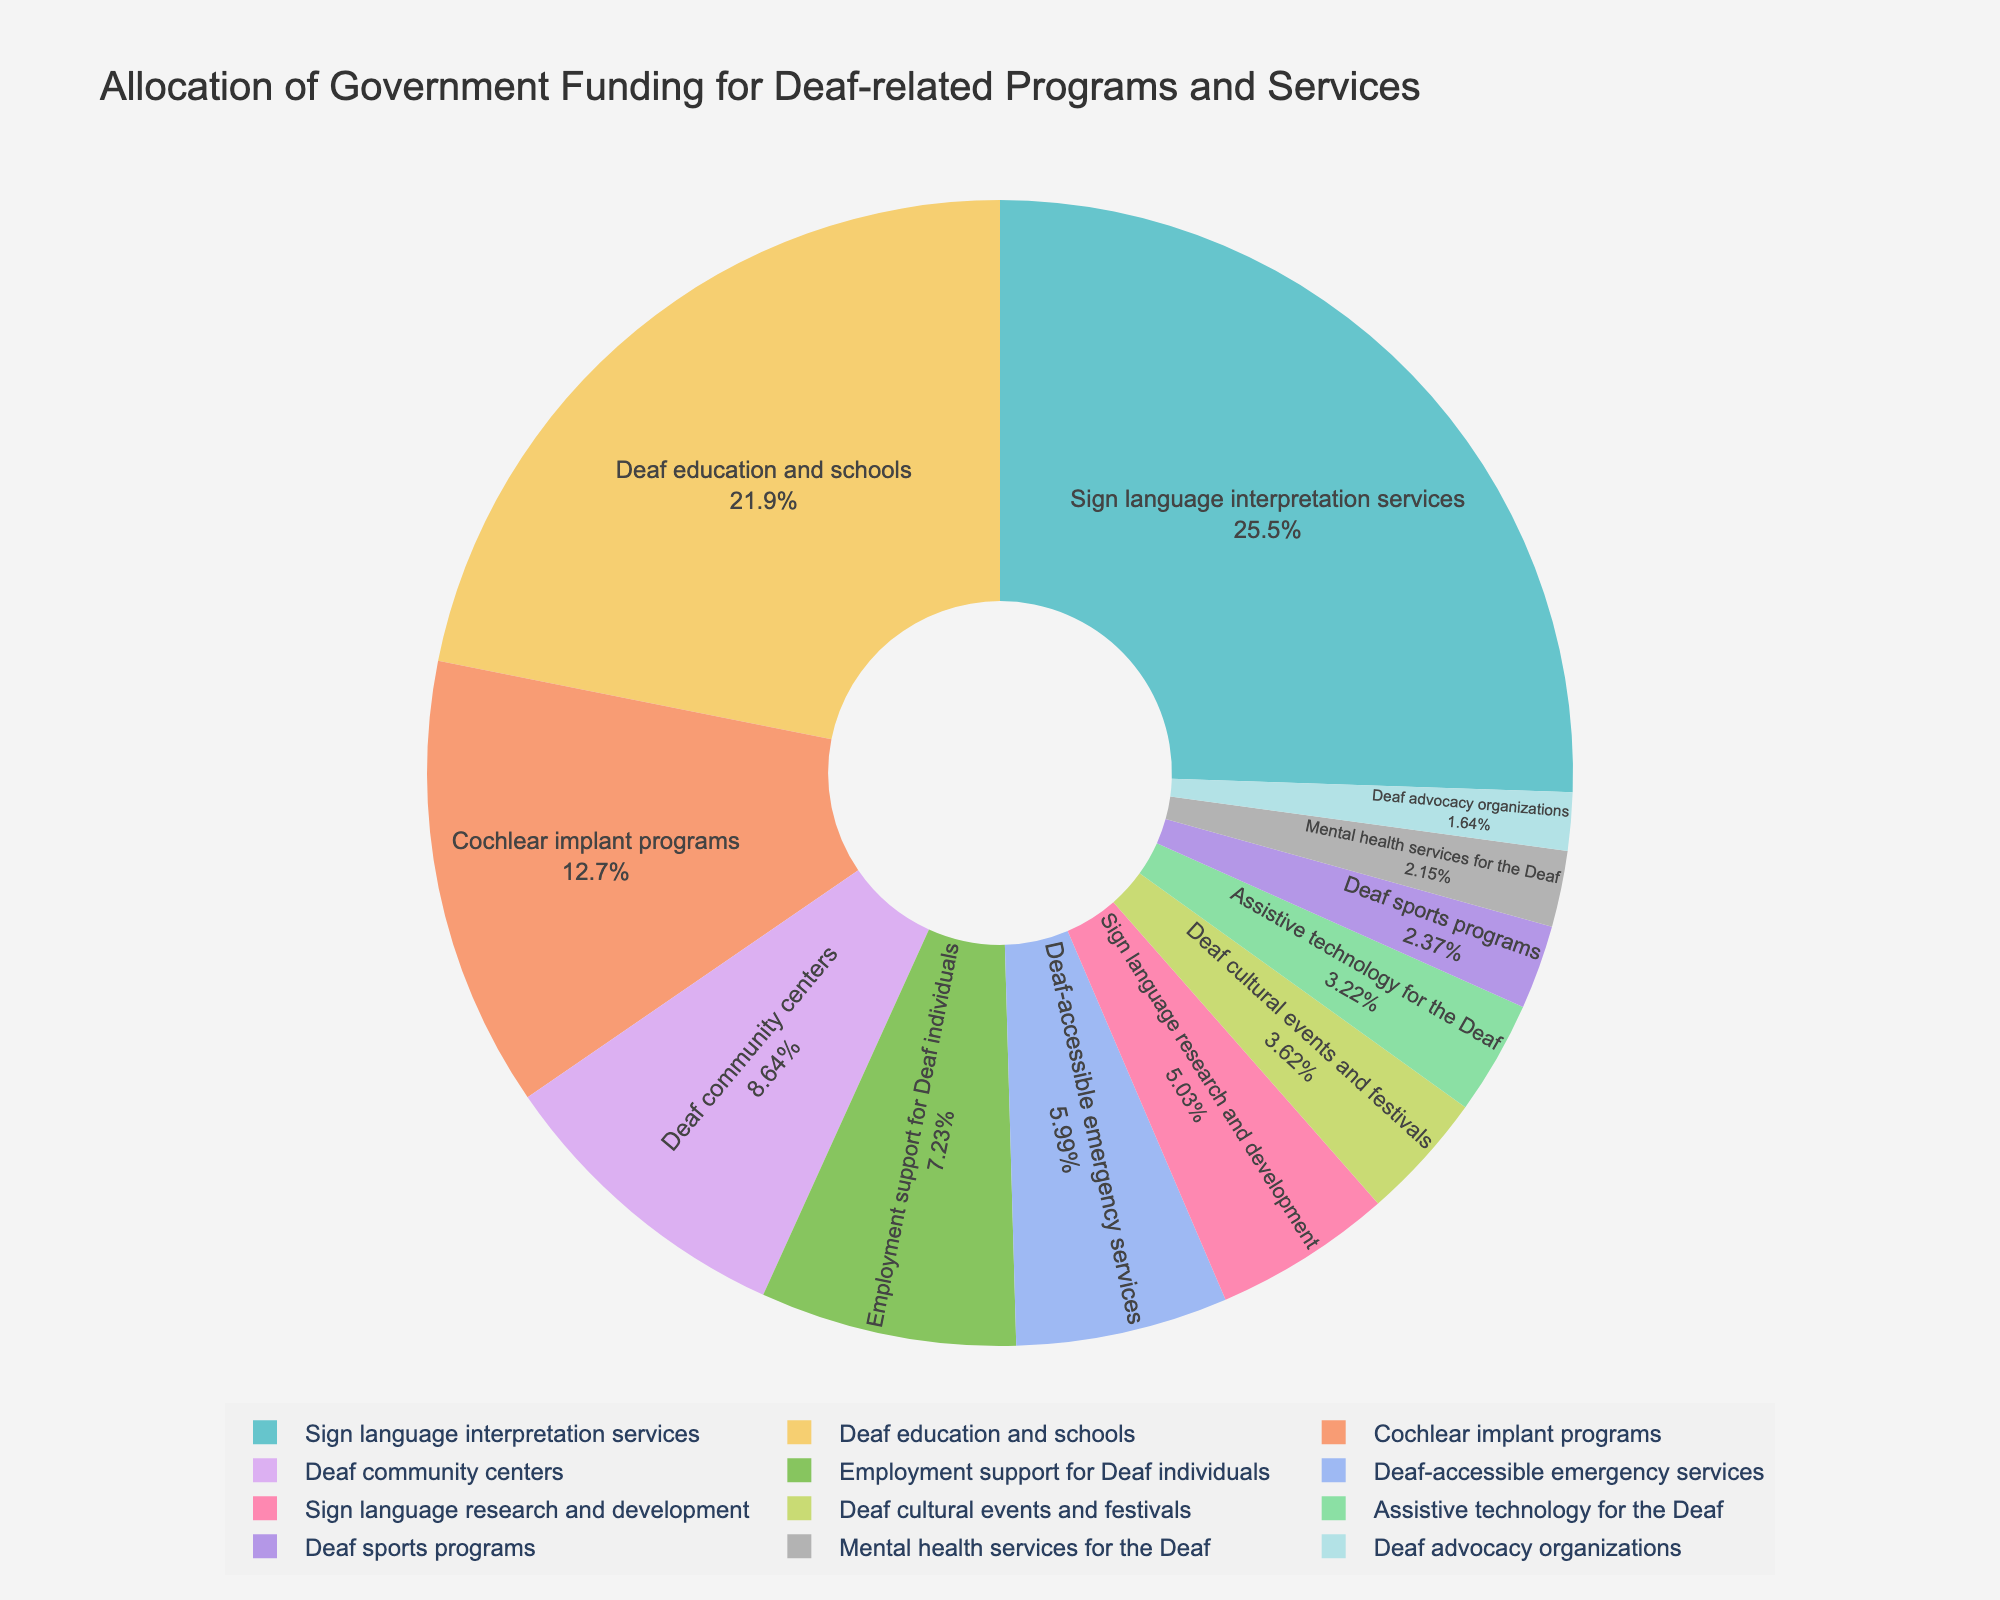Which category receives the highest funding? The pie chart shows slices representing different funding categories. The largest slice is for Sign language interpretation services.
Answer: Sign language interpretation services How many funding categories receive more than €20 million? By looking at the pie chart, we see that the slices for Sign language interpretation services, Deaf education and schools, and Cochlear implant programs each exceed €20 million.
Answer: 3 What is the combined funding for Sign language research and development and Mental health services for the Deaf? By locating each category in the pie chart and adding their funding amounts, we get €8.9 million + €3.8 million = €12.7 million.
Answer: €12.7 million Which service receives the least funding? The smallest slice in the pie chart is for Deaf advocacy organizations, indicating it receives the least funding.
Answer: Deaf advocacy organizations Is the funding for Deaf community centers greater than the funding for Employment support for Deaf individuals? By comparing the slices, the pie chart shows that Deaf community centers receive €15.3 million, which is greater than €12.8 million for Employment support for Deaf individuals.
Answer: Yes What percentage of the total funding goes to Assistive technology for the Deaf? The pie chart provides this information directly. The slice labeled Assistive technology for the Deaf shows the percentage of total funding it receives.
Answer: Approximately 2.8% By how much does the funding for Deaf-accessible emergency services differ from that for Deaf sports programs? Locate and compare the slices for Deaf-accessible emergency services (€10.6 million) and Deaf sports programs (€4.2 million), then subtract: €10.6 million - €4.2 million = €6.4 million.
Answer: €6.4 million Which funding category gets nearly twice the amount of funding compared to another? We see that Sign language interpretation services (€45.2 million) is nearly twice the funding of Deaf education and schools (€38.7 million). Similarly, Cochlear implant programs (€22.5 million) receive nearly double the funding of Deaf community centers (€15.3 million) (but not exactly). Examine relationships for multiple categories.
Answer: Sign language interpretation services vs. Deaf education and schools What is the average funding amount across all categories? Sum all the funding amounts and divide by the number of categories: (€45.2 + €38.7 + €22.5 + €15.3 + €12.8 + €10.6 + €8.9 + €6.4 + €5.7 + €4.2 + €3.8 + €2.9) / 12 = €167 / 12 ≈ €13.9 million.
Answer: €13.9 million Is the funding for Deaf cultural events and festivals less than €10 million? By viewing the pie chart and locating the slice for Deaf cultural events and festivals, which shows €6.4 million, it’s clear this is less than €10 million.
Answer: Yes 